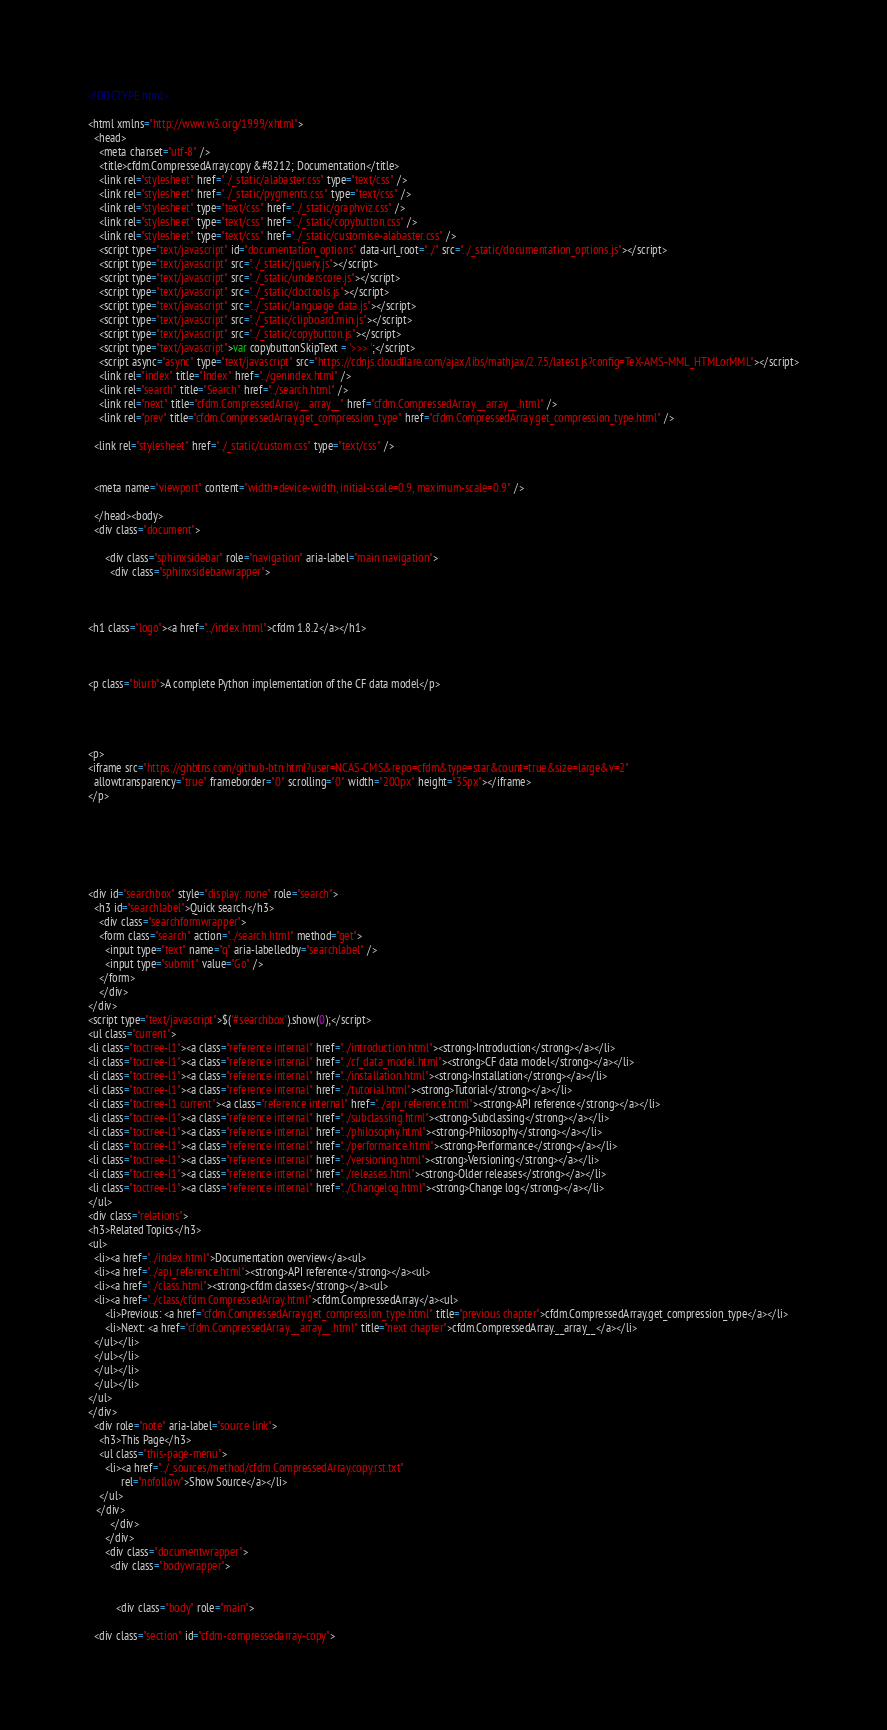Convert code to text. <code><loc_0><loc_0><loc_500><loc_500><_HTML_>
<!DOCTYPE html>

<html xmlns="http://www.w3.org/1999/xhtml">
  <head>
    <meta charset="utf-8" />
    <title>cfdm.CompressedArray.copy &#8212; Documentation</title>
    <link rel="stylesheet" href="../_static/alabaster.css" type="text/css" />
    <link rel="stylesheet" href="../_static/pygments.css" type="text/css" />
    <link rel="stylesheet" type="text/css" href="../_static/graphviz.css" />
    <link rel="stylesheet" type="text/css" href="../_static/copybutton.css" />
    <link rel="stylesheet" type="text/css" href="../_static/customise-alabaster.css" />
    <script type="text/javascript" id="documentation_options" data-url_root="../" src="../_static/documentation_options.js"></script>
    <script type="text/javascript" src="../_static/jquery.js"></script>
    <script type="text/javascript" src="../_static/underscore.js"></script>
    <script type="text/javascript" src="../_static/doctools.js"></script>
    <script type="text/javascript" src="../_static/language_data.js"></script>
    <script type="text/javascript" src="../_static/clipboard.min.js"></script>
    <script type="text/javascript" src="../_static/copybutton.js"></script>
    <script type="text/javascript">var copybuttonSkipText = '>>> ';</script>
    <script async="async" type="text/javascript" src="https://cdnjs.cloudflare.com/ajax/libs/mathjax/2.7.5/latest.js?config=TeX-AMS-MML_HTMLorMML"></script>
    <link rel="index" title="Index" href="../genindex.html" />
    <link rel="search" title="Search" href="../search.html" />
    <link rel="next" title="cfdm.CompressedArray.__array__" href="cfdm.CompressedArray.__array__.html" />
    <link rel="prev" title="cfdm.CompressedArray.get_compression_type" href="cfdm.CompressedArray.get_compression_type.html" />
   
  <link rel="stylesheet" href="../_static/custom.css" type="text/css" />
  
  
  <meta name="viewport" content="width=device-width, initial-scale=0.9, maximum-scale=0.9" />

  </head><body>
  <div class="document">
    
      <div class="sphinxsidebar" role="navigation" aria-label="main navigation">
        <div class="sphinxsidebarwrapper">



<h1 class="logo"><a href="../index.html">cfdm 1.8.2</a></h1>



<p class="blurb">A complete Python implementation of the CF data model</p>




<p>
<iframe src="https://ghbtns.com/github-btn.html?user=NCAS-CMS&repo=cfdm&type=star&count=true&size=large&v=2"
  allowtransparency="true" frameborder="0" scrolling="0" width="200px" height="35px"></iframe>
</p>






<div id="searchbox" style="display: none" role="search">
  <h3 id="searchlabel">Quick search</h3>
    <div class="searchformwrapper">
    <form class="search" action="../search.html" method="get">
      <input type="text" name="q" aria-labelledby="searchlabel" />
      <input type="submit" value="Go" />
    </form>
    </div>
</div>
<script type="text/javascript">$('#searchbox').show(0);</script>
<ul class="current">
<li class="toctree-l1"><a class="reference internal" href="../introduction.html"><strong>Introduction</strong></a></li>
<li class="toctree-l1"><a class="reference internal" href="../cf_data_model.html"><strong>CF data model</strong></a></li>
<li class="toctree-l1"><a class="reference internal" href="../installation.html"><strong>Installation</strong></a></li>
<li class="toctree-l1"><a class="reference internal" href="../tutorial.html"><strong>Tutorial</strong></a></li>
<li class="toctree-l1 current"><a class="reference internal" href="../api_reference.html"><strong>API reference</strong></a></li>
<li class="toctree-l1"><a class="reference internal" href="../subclassing.html"><strong>Subclassing</strong></a></li>
<li class="toctree-l1"><a class="reference internal" href="../philosophy.html"><strong>Philosophy</strong></a></li>
<li class="toctree-l1"><a class="reference internal" href="../performance.html"><strong>Performance</strong></a></li>
<li class="toctree-l1"><a class="reference internal" href="../versioning.html"><strong>Versioning</strong></a></li>
<li class="toctree-l1"><a class="reference internal" href="../releases.html"><strong>Older releases</strong></a></li>
<li class="toctree-l1"><a class="reference internal" href="../Changelog.html"><strong>Change log</strong></a></li>
</ul>
<div class="relations">
<h3>Related Topics</h3>
<ul>
  <li><a href="../index.html">Documentation overview</a><ul>
  <li><a href="../api_reference.html"><strong>API reference</strong></a><ul>
  <li><a href="../class.html"><strong>cfdm classes</strong></a><ul>
  <li><a href="../class/cfdm.CompressedArray.html">cfdm.CompressedArray</a><ul>
      <li>Previous: <a href="cfdm.CompressedArray.get_compression_type.html" title="previous chapter">cfdm.CompressedArray.get_compression_type</a></li>
      <li>Next: <a href="cfdm.CompressedArray.__array__.html" title="next chapter">cfdm.CompressedArray.__array__</a></li>
  </ul></li>
  </ul></li>
  </ul></li>
  </ul></li>
</ul>
</div>
  <div role="note" aria-label="source link">
    <h3>This Page</h3>
    <ul class="this-page-menu">
      <li><a href="../_sources/method/cfdm.CompressedArray.copy.rst.txt"
            rel="nofollow">Show Source</a></li>
    </ul>
   </div>
        </div>
      </div>
      <div class="documentwrapper">
        <div class="bodywrapper">
          

          <div class="body" role="main">
            
  <div class="section" id="cfdm-compressedarray-copy"></code> 